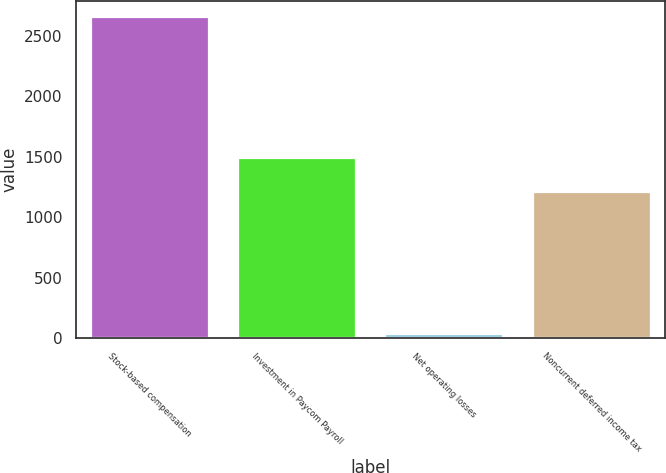Convert chart. <chart><loc_0><loc_0><loc_500><loc_500><bar_chart><fcel>Stock-based compensation<fcel>Investment in Paycom Payroll<fcel>Net operating losses<fcel>Noncurrent deferred income tax<nl><fcel>2658<fcel>1487<fcel>36<fcel>1207<nl></chart> 